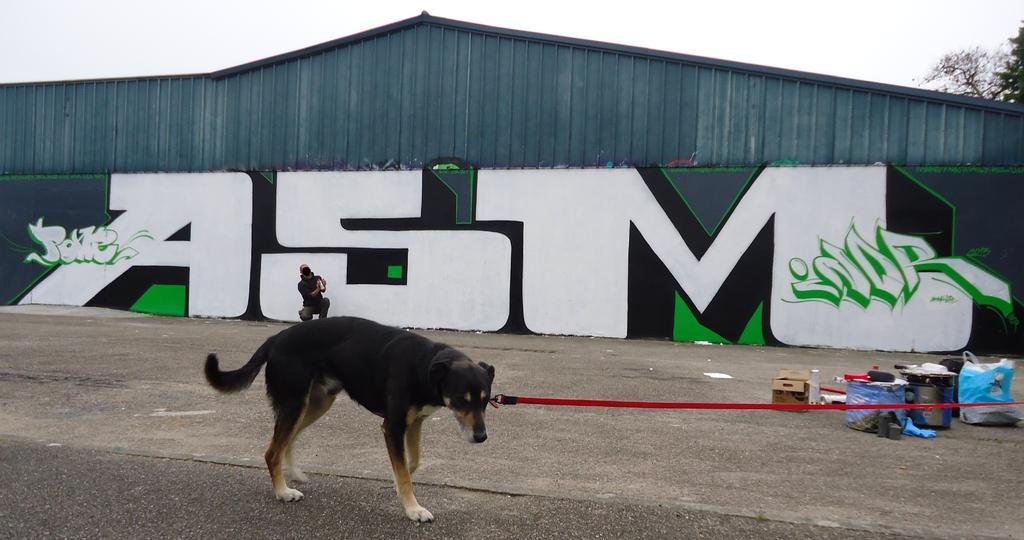Could you give a brief overview of what you see in this image? In this picture, we can see a shed and some art on it, we can see a person, dog with a belt, and we can see the ground with some objects on it like bags, containers, bottles, and we can see some trees and the sky. 